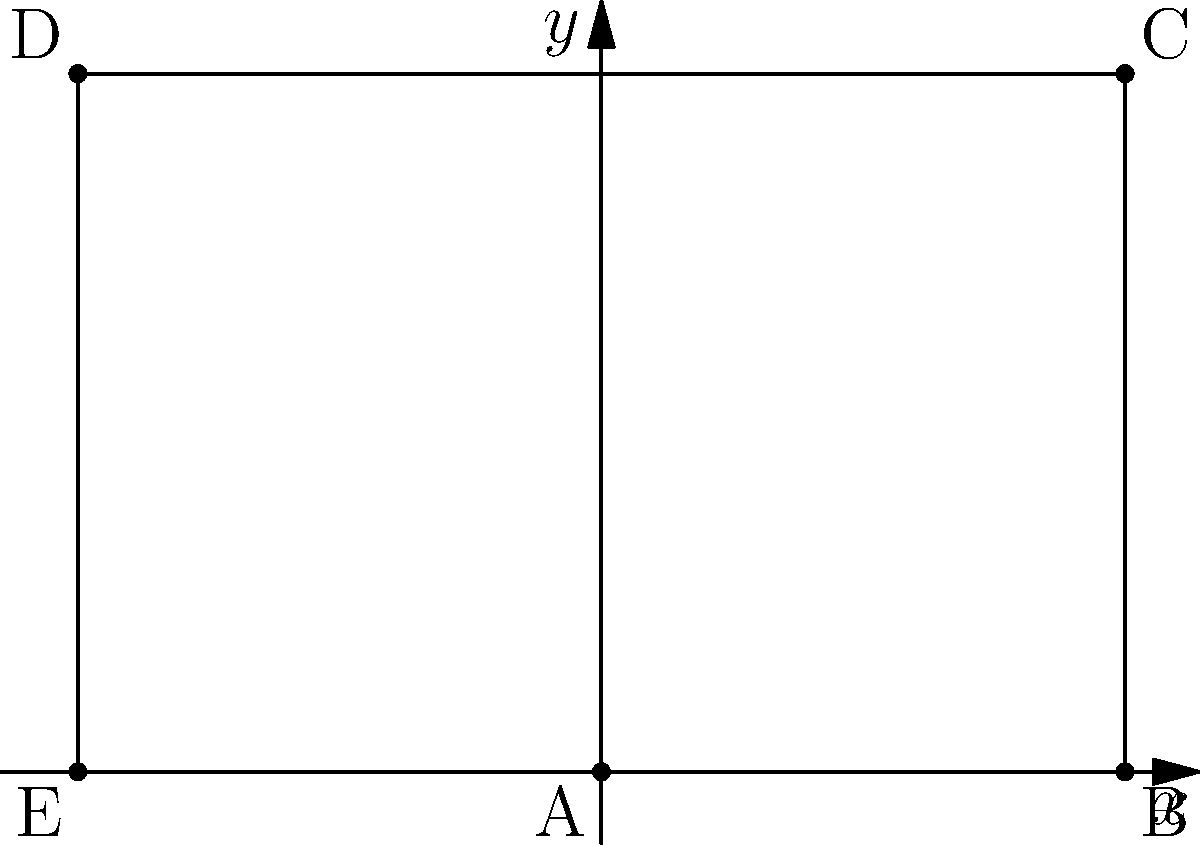In the Cartesian plane above, points have been plotted to form a specific shape. What is the area of the resulting shape? Provide your answer in square units. To find the area of the shape, we need to follow these steps:

1) Identify the shape: The plotted points form a pentagon.

2) Divide the pentagon into simpler shapes: We can split it into a rectangle and a right triangle.

3) Calculate the area of the rectangle:
   - Width = distance between points E and B = 6 units
   - Height = distance between points B and C = 4 units
   - Area of rectangle = $6 \times 4 = 24$ square units

4) Calculate the area of the right triangle:
   - Base = distance between points A and E = 3 units
   - Height = same as the rectangle's height = 4 units
   - Area of triangle = $\frac{1}{2} \times 3 \times 4 = 6$ square units

5) Sum the areas:
   Total Area = Area of rectangle + Area of triangle
               = $24 + 6 = 30$ square units

Therefore, the area of the shape is 30 square units.
Answer: 30 square units 